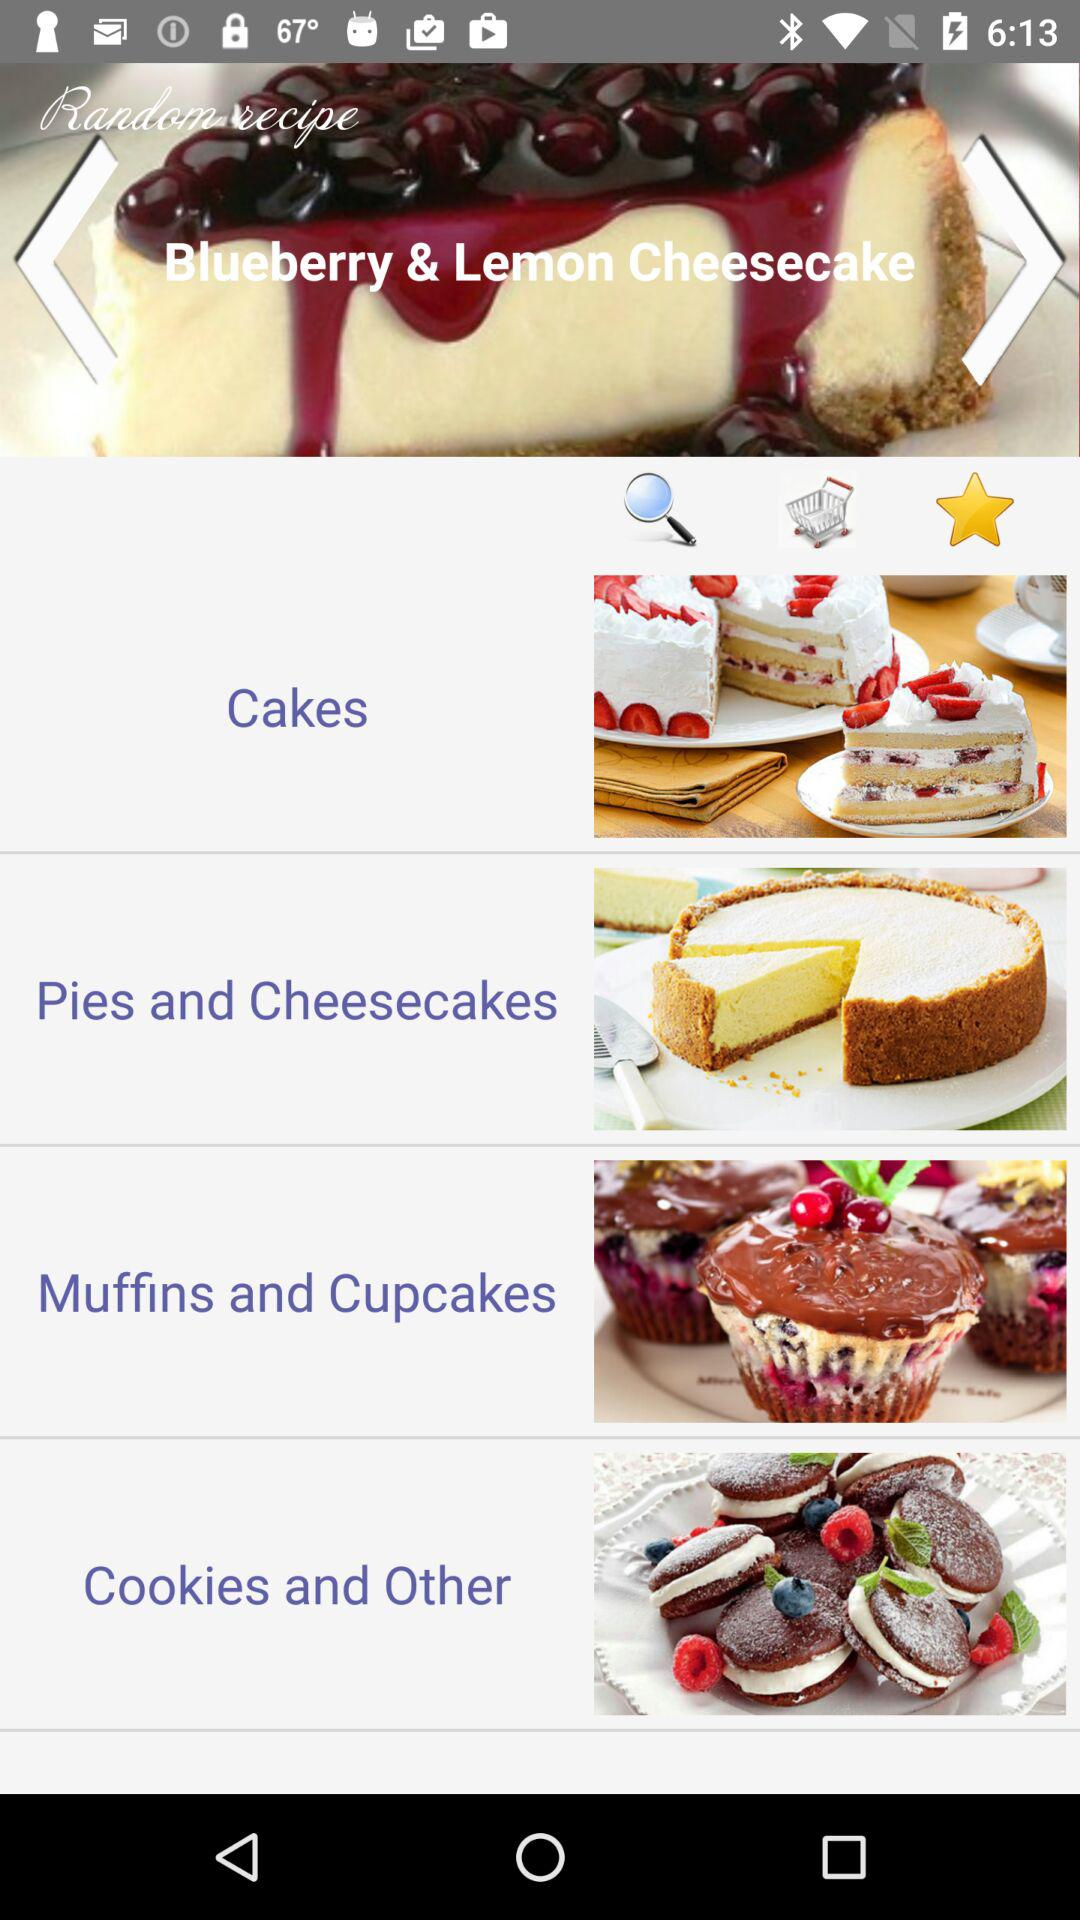What is the name of the recipe on the screen? The name of the recipe on the screen is "Blueberry & Lemon Cheesecake". 